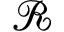Convert formula to latex. <formula><loc_0><loc_0><loc_500><loc_500>\mathcal { R }</formula> 